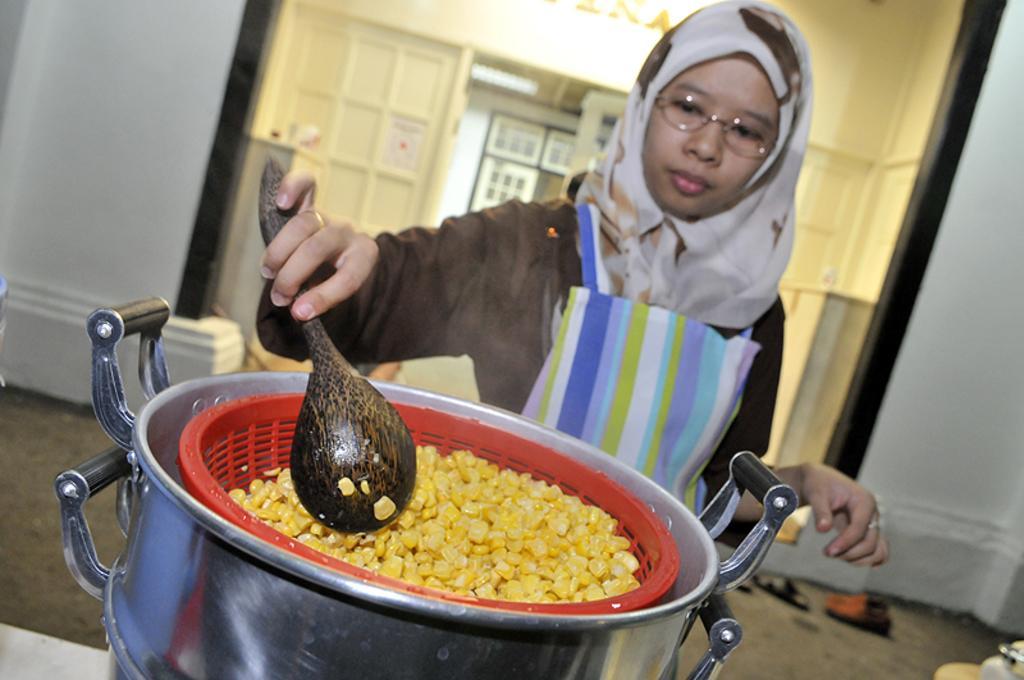Can you describe this image briefly? In the given image i can see a person cooking a food item in the silver metal. 